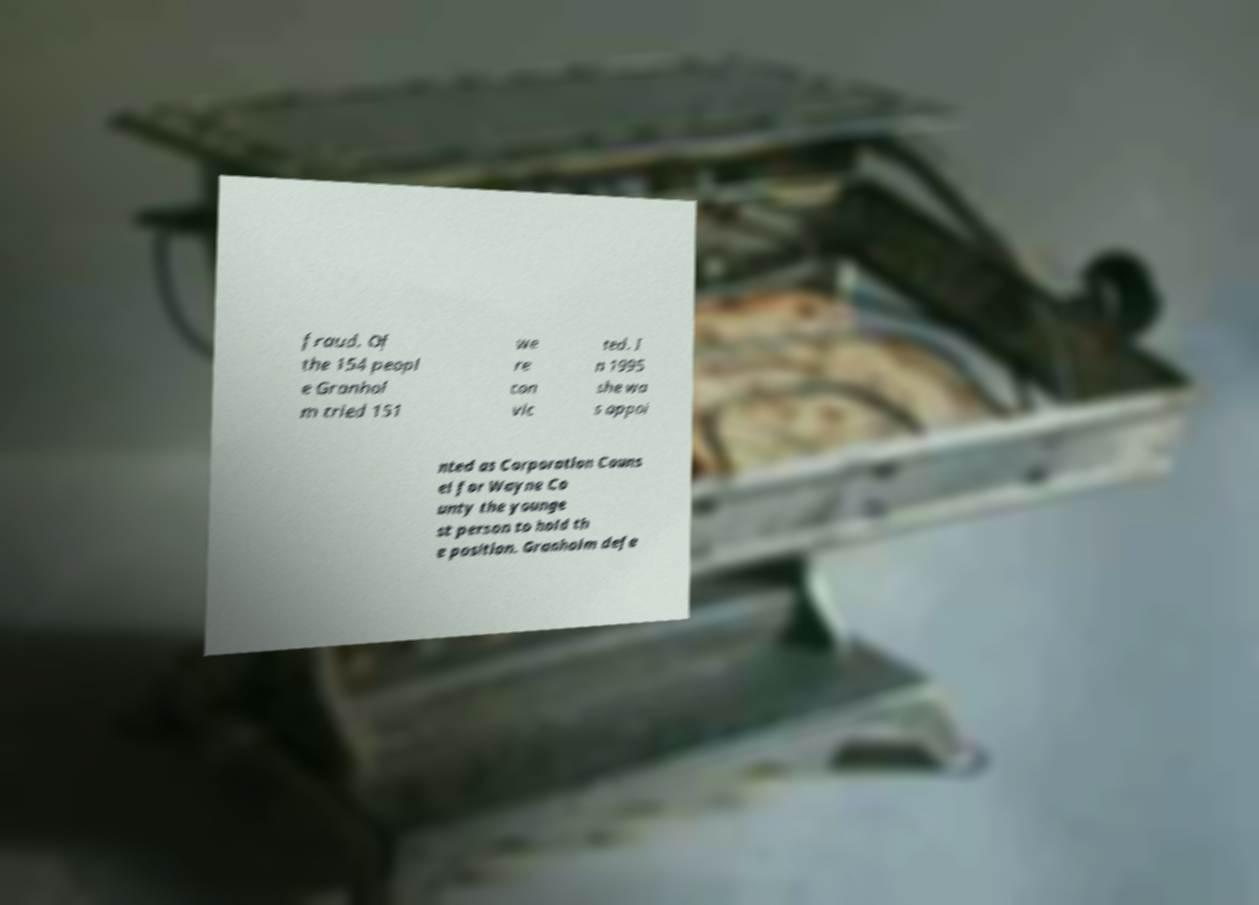What messages or text are displayed in this image? I need them in a readable, typed format. fraud. Of the 154 peopl e Granhol m tried 151 we re con vic ted. I n 1995 she wa s appoi nted as Corporation Couns el for Wayne Co unty the younge st person to hold th e position. Granholm defe 